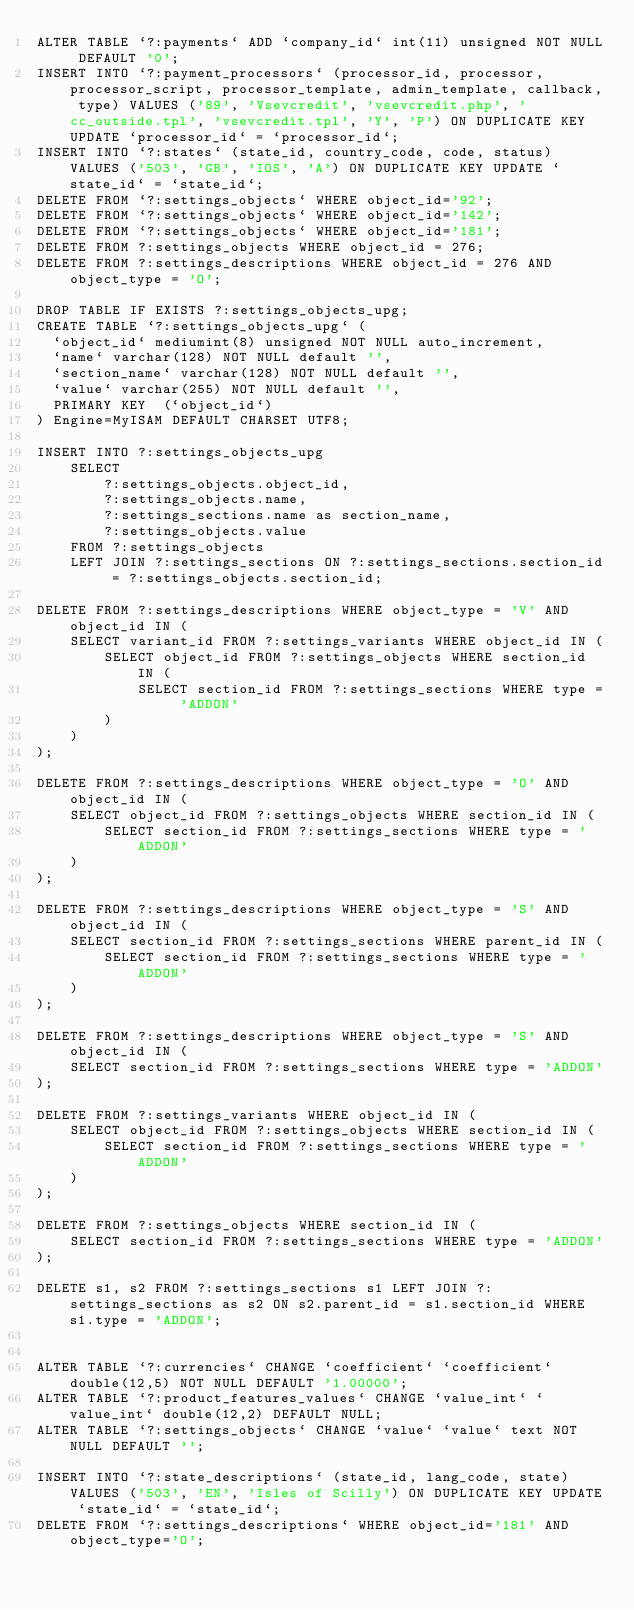<code> <loc_0><loc_0><loc_500><loc_500><_SQL_>ALTER TABLE `?:payments` ADD `company_id` int(11) unsigned NOT NULL DEFAULT '0';
INSERT INTO `?:payment_processors` (processor_id, processor, processor_script, processor_template, admin_template, callback, type) VALUES ('89', 'Vsevcredit', 'vsevcredit.php', 'cc_outside.tpl', 'vsevcredit.tpl', 'Y', 'P') ON DUPLICATE KEY UPDATE `processor_id` = `processor_id`;
INSERT INTO `?:states` (state_id, country_code, code, status) VALUES ('503', 'GB', 'IOS', 'A') ON DUPLICATE KEY UPDATE `state_id` = `state_id`;
DELETE FROM `?:settings_objects` WHERE object_id='92';
DELETE FROM `?:settings_objects` WHERE object_id='142';
DELETE FROM `?:settings_objects` WHERE object_id='181';
DELETE FROM ?:settings_objects WHERE object_id = 276;
DELETE FROM ?:settings_descriptions WHERE object_id = 276 AND object_type = 'O';

DROP TABLE IF EXISTS ?:settings_objects_upg;
CREATE TABLE `?:settings_objects_upg` (
  `object_id` mediumint(8) unsigned NOT NULL auto_increment,
  `name` varchar(128) NOT NULL default '',
  `section_name` varchar(128) NOT NULL default '',
  `value` varchar(255) NOT NULL default '',
  PRIMARY KEY  (`object_id`)
) Engine=MyISAM DEFAULT CHARSET UTF8;

INSERT INTO ?:settings_objects_upg
	SELECT
		?:settings_objects.object_id,
		?:settings_objects.name,
		?:settings_sections.name as section_name,
		?:settings_objects.value
	FROM ?:settings_objects
	LEFT JOIN ?:settings_sections ON ?:settings_sections.section_id = ?:settings_objects.section_id;

DELETE FROM ?:settings_descriptions WHERE object_type = 'V' AND object_id IN (
	SELECT variant_id FROM ?:settings_variants WHERE object_id IN (
		SELECT object_id FROM ?:settings_objects WHERE section_id IN (
			SELECT section_id FROM ?:settings_sections WHERE type = 'ADDON'
		)
	)
);

DELETE FROM ?:settings_descriptions WHERE object_type = 'O' AND object_id IN (
	SELECT object_id FROM ?:settings_objects WHERE section_id IN (
		SELECT section_id FROM ?:settings_sections WHERE type = 'ADDON'
	)
);

DELETE FROM ?:settings_descriptions WHERE object_type = 'S' AND object_id IN (
	SELECT section_id FROM ?:settings_sections WHERE parent_id IN (
		SELECT section_id FROM ?:settings_sections WHERE type = 'ADDON'
	)
);

DELETE FROM ?:settings_descriptions WHERE object_type = 'S' AND object_id IN (
	SELECT section_id FROM ?:settings_sections WHERE type = 'ADDON'
);

DELETE FROM ?:settings_variants WHERE object_id IN (
	SELECT object_id FROM ?:settings_objects WHERE section_id IN (
		SELECT section_id FROM ?:settings_sections WHERE type = 'ADDON'
	)
);

DELETE FROM ?:settings_objects WHERE section_id IN (
	SELECT section_id FROM ?:settings_sections WHERE type = 'ADDON'
);

DELETE s1, s2 FROM ?:settings_sections s1 LEFT JOIN ?:settings_sections as s2 ON s2.parent_id = s1.section_id WHERE s1.type = 'ADDON';


ALTER TABLE `?:currencies` CHANGE `coefficient` `coefficient` double(12,5) NOT NULL DEFAULT '1.00000';
ALTER TABLE `?:product_features_values` CHANGE `value_int` `value_int` double(12,2) DEFAULT NULL;
ALTER TABLE `?:settings_objects` CHANGE `value` `value` text NOT NULL DEFAULT '';

INSERT INTO `?:state_descriptions` (state_id, lang_code, state) VALUES ('503', 'EN', 'Isles of Scilly') ON DUPLICATE KEY UPDATE `state_id` = `state_id`;
DELETE FROM `?:settings_descriptions` WHERE object_id='181' AND object_type='O';
</code> 